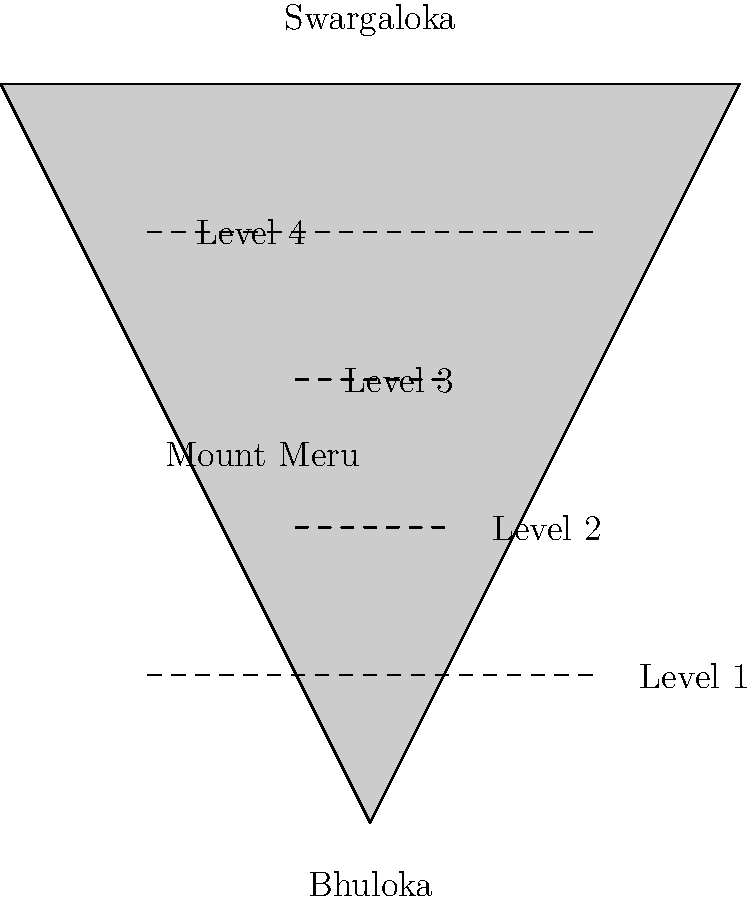According to Hindu cosmology, Mount Meru is divided into several levels. Based on the diagram, how many distinct levels are shown on Mount Meru, and what are the names of the realms at the base and peak of the mountain? To answer this question, let's analyze the diagram step-by-step:

1. Count the levels:
   The diagram shows dashed lines across Mount Meru, each representing a distinct level.
   Counting these lines, we can see there are 4 levels clearly marked.

2. Identify the realm at the base:
   At the bottom of Mount Meru, we see the label "Bhuloka".
   In Hindu cosmology, Bhuloka represents the earthly realm or the world of humans.

3. Identify the realm at the peak:
   At the top of Mount Meru, we see the label "Swargaloka".
   Swargaloka in Hindu mythology refers to the heavenly realm or the abode of the gods.

4. Synthesize the information:
   The question asks for the number of distinct levels and the names of the realms at the base and peak.
   We have identified 4 levels, with Bhuloka at the base and Swargaloka at the peak.

Therefore, the complete answer is: 4 levels, with Bhuloka at the base and Swargaloka at the peak.
Answer: 4 levels; Bhuloka (base), Swargaloka (peak) 